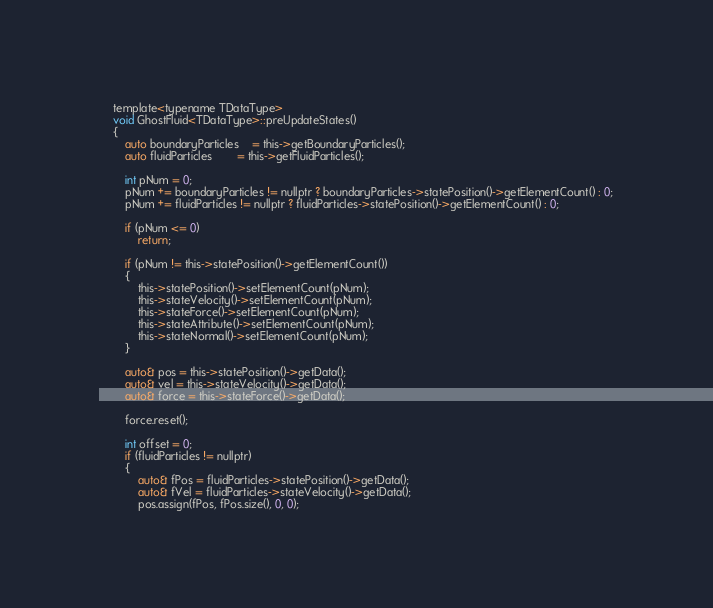<code> <loc_0><loc_0><loc_500><loc_500><_Cuda_>
	template<typename TDataType>
	void GhostFluid<TDataType>::preUpdateStates()
	{
		auto boundaryParticles	= this->getBoundaryParticles();
		auto fluidParticles		= this->getFluidParticles();

		int pNum = 0;
		pNum += boundaryParticles != nullptr ? boundaryParticles->statePosition()->getElementCount() : 0;
		pNum += fluidParticles != nullptr ? fluidParticles->statePosition()->getElementCount() : 0;

		if (pNum <= 0)
			return;

		if (pNum != this->statePosition()->getElementCount())
		{
			this->statePosition()->setElementCount(pNum);
			this->stateVelocity()->setElementCount(pNum);
			this->stateForce()->setElementCount(pNum);
			this->stateAttribute()->setElementCount(pNum);
			this->stateNormal()->setElementCount(pNum);
		}

		auto& pos = this->statePosition()->getData();
		auto& vel = this->stateVelocity()->getData();
		auto& force = this->stateForce()->getData();

		force.reset();

		int offset = 0;
		if (fluidParticles != nullptr)
		{
			auto& fPos = fluidParticles->statePosition()->getData();
			auto& fVel = fluidParticles->stateVelocity()->getData();
			pos.assign(fPos, fPos.size(), 0, 0);</code> 